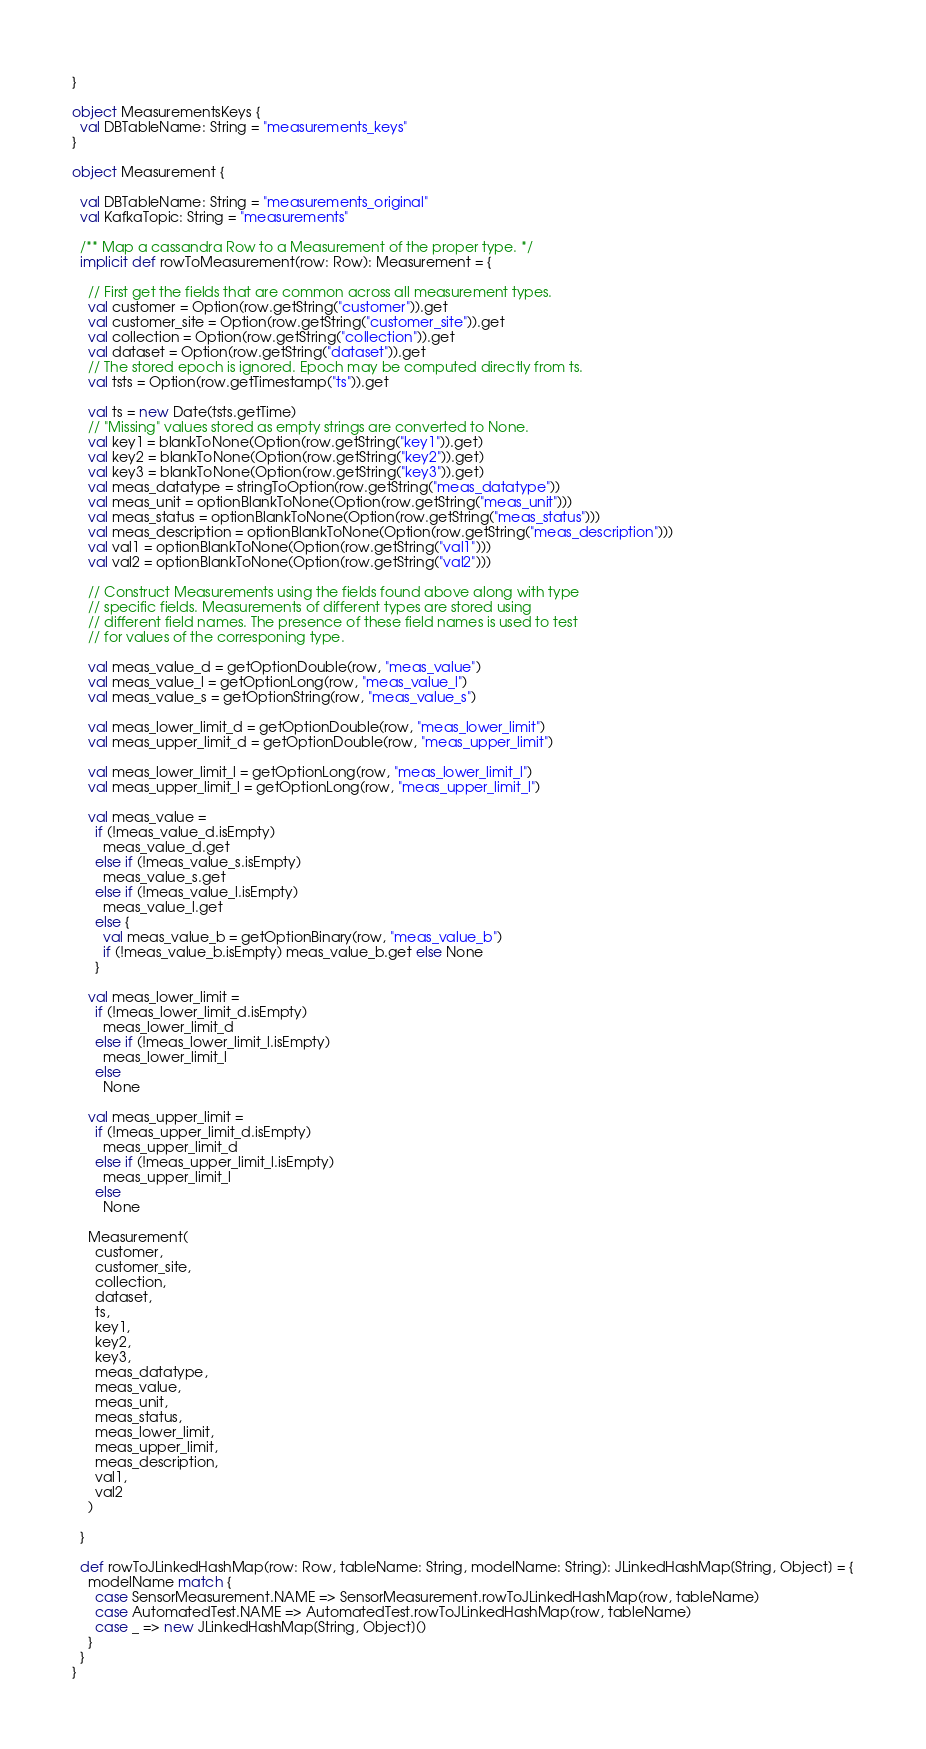<code> <loc_0><loc_0><loc_500><loc_500><_Scala_>}

object MeasurementsKeys {
  val DBTableName: String = "measurements_keys"
}

object Measurement {

  val DBTableName: String = "measurements_original"
  val KafkaTopic: String = "measurements"

  /** Map a cassandra Row to a Measurement of the proper type. */
  implicit def rowToMeasurement(row: Row): Measurement = {

    // First get the fields that are common across all measurement types.
    val customer = Option(row.getString("customer")).get
    val customer_site = Option(row.getString("customer_site")).get
    val collection = Option(row.getString("collection")).get
    val dataset = Option(row.getString("dataset")).get
    // The stored epoch is ignored. Epoch may be computed directly from ts.
    val tsts = Option(row.getTimestamp("ts")).get

    val ts = new Date(tsts.getTime)
    // "Missing" values stored as empty strings are converted to None.
    val key1 = blankToNone(Option(row.getString("key1")).get)
    val key2 = blankToNone(Option(row.getString("key2")).get)
    val key3 = blankToNone(Option(row.getString("key3")).get)
    val meas_datatype = stringToOption(row.getString("meas_datatype"))
    val meas_unit = optionBlankToNone(Option(row.getString("meas_unit")))
    val meas_status = optionBlankToNone(Option(row.getString("meas_status")))
    val meas_description = optionBlankToNone(Option(row.getString("meas_description")))
    val val1 = optionBlankToNone(Option(row.getString("val1")))
    val val2 = optionBlankToNone(Option(row.getString("val2")))

    // Construct Measurements using the fields found above along with type
    // specific fields. Measurements of different types are stored using
    // different field names. The presence of these field names is used to test
    // for values of the corresponing type.

    val meas_value_d = getOptionDouble(row, "meas_value")
    val meas_value_l = getOptionLong(row, "meas_value_l")
    val meas_value_s = getOptionString(row, "meas_value_s")

    val meas_lower_limit_d = getOptionDouble(row, "meas_lower_limit")
    val meas_upper_limit_d = getOptionDouble(row, "meas_upper_limit")

    val meas_lower_limit_l = getOptionLong(row, "meas_lower_limit_l")
    val meas_upper_limit_l = getOptionLong(row, "meas_upper_limit_l")

    val meas_value =
      if (!meas_value_d.isEmpty)
        meas_value_d.get
      else if (!meas_value_s.isEmpty)
        meas_value_s.get
      else if (!meas_value_l.isEmpty)
        meas_value_l.get
      else {
        val meas_value_b = getOptionBinary(row, "meas_value_b")
        if (!meas_value_b.isEmpty) meas_value_b.get else None
      }

    val meas_lower_limit =
      if (!meas_lower_limit_d.isEmpty)
        meas_lower_limit_d
      else if (!meas_lower_limit_l.isEmpty)
        meas_lower_limit_l
      else
        None

    val meas_upper_limit =
      if (!meas_upper_limit_d.isEmpty)
        meas_upper_limit_d
      else if (!meas_upper_limit_l.isEmpty)
        meas_upper_limit_l
      else
        None

    Measurement(
      customer,
      customer_site,
      collection,
      dataset,
      ts,
      key1,
      key2,
      key3,
      meas_datatype,
      meas_value,
      meas_unit,
      meas_status,
      meas_lower_limit,
      meas_upper_limit,
      meas_description,
      val1,
      val2
    )

  }

  def rowToJLinkedHashMap(row: Row, tableName: String, modelName: String): JLinkedHashMap[String, Object] = {
    modelName match {
      case SensorMeasurement.NAME => SensorMeasurement.rowToJLinkedHashMap(row, tableName)
      case AutomatedTest.NAME => AutomatedTest.rowToJLinkedHashMap(row, tableName)
      case _ => new JLinkedHashMap[String, Object]()
    }
  }
}
</code> 